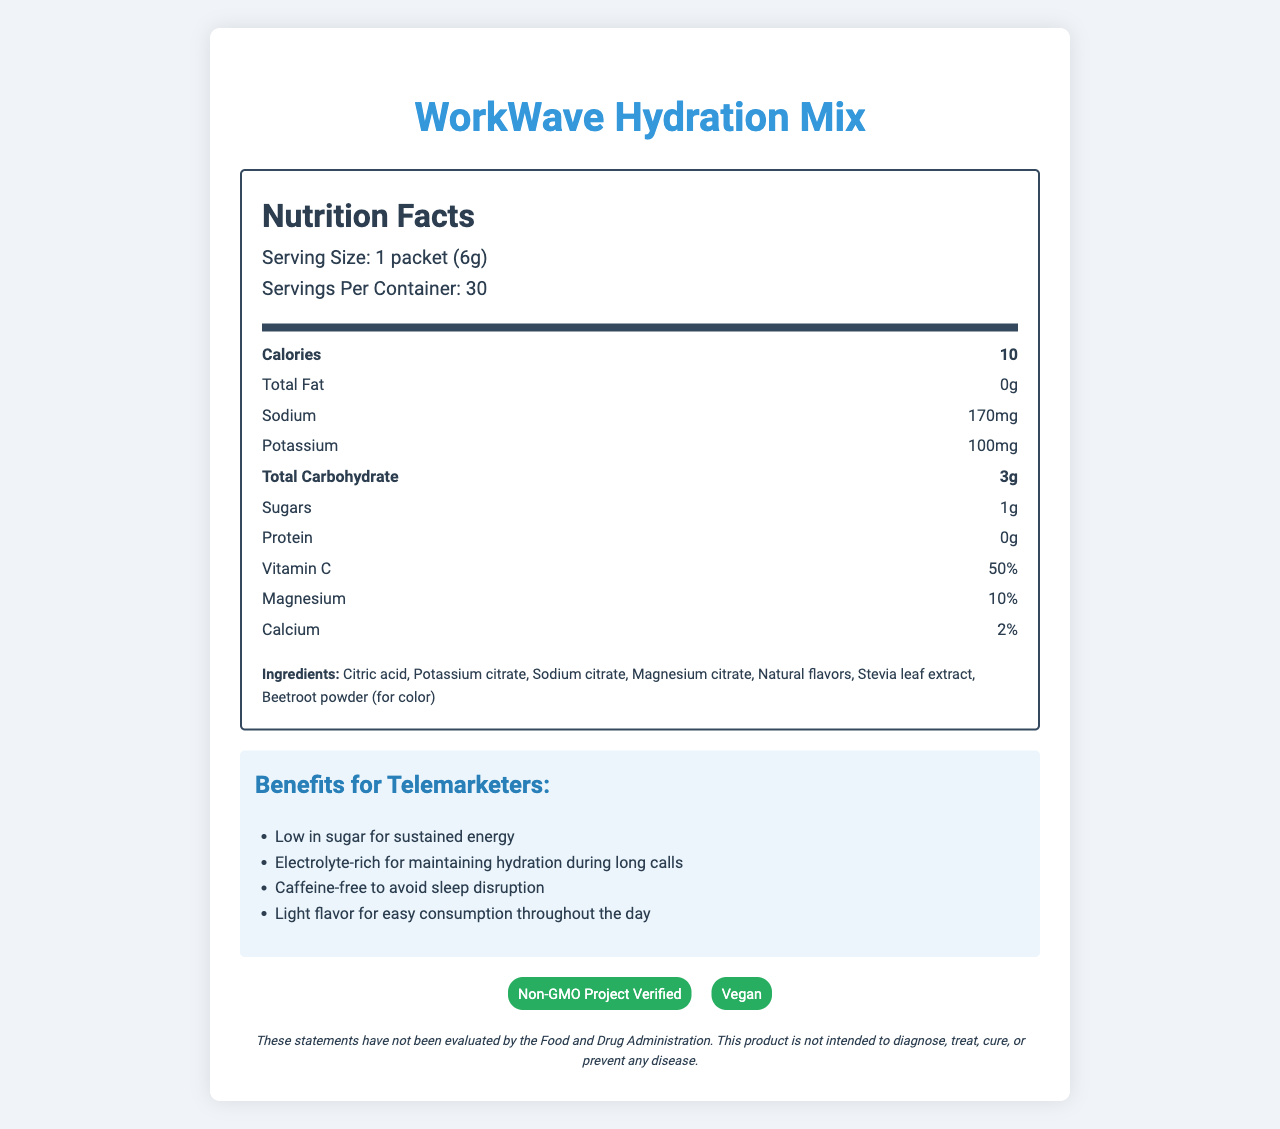What is the serving size of WorkWave Hydration Mix? The serving size is clearly stated under the nutrition facts header where it mentions "Serving Size: 1 packet (6g)."
Answer: 1 packet (6g) How many calories are in one serving of the hydration mix? The number of calories per serving is listed directly in the nutrition facts, stating "Calories: 10".
Answer: 10 What is the main benefit of the WorkWave Hydration Mix for telemarketers? The benefits are listed in a dedicated section, with "Low in sugar for sustained energy" being one of the primary benefits highlighted.
Answer: Low in sugar for sustained energy What percentage of Daily Value is the Vitamin C in one serving? Under the nutrition facts, it mentions "Vitamin C: 50%."
Answer: 50% What facilities does WorkWave Hydration Mix get processed in? This information is listed in the allergen information section near the bottom of the document.
Answer: Produced in a facility that also processes soy and milk Which of the following ingredients are in the WorkWave Hydration Mix? (Select all that apply) A. Citric acid B. Stevia leaf extract C. Beetroot powder D. High fructose corn syrup E. Artificial flavors The ingredients section lists "Citric acid", "Stevia leaf extract", and "Beetroot powder (for color)" but does not mention "High fructose corn syrup" or "Artificial flavors".
Answer: A, B, C What are two certifications held by the WorkWave Hydration Mix? The certifications section at the bottom of the document lists "Non-GMO Project Verified" and "Vegan."
Answer: Non-GMO Project Verified, Vegan Is this product suitable for someone avoiding caffeine? The benefits section mentions that the drink mix is "Caffeine-free to avoid sleep disruption," which confirms it is suitable for someone avoiding caffeine.
Answer: Yes Does WorkWave Hydration Mix contain any fat? The nutrition facts clearly state "Total Fat: 0g."
Answer: No Summarize the main points of the WorkWave Hydration Mix document. The detailed explanation of the document includes an overview of the product benefits for telemarketers, nutritional values, ingredients, allergen information, and certifications.
Answer: The WorkWave Hydration Mix is a low-sugar, electrolyte-rich drink mix designed specifically for telemarketers to maintain hydration and energy during work hours. It contains 10 calories per serving, is caffeine-free, and is produced in a facility that processes soy and milk. The mix comes with several benefits such as being Non-GMO Project Verified and Vegan, and designed to be light-tasting and easily consumable throughout the day. The document includes detailed nutritional information, ingredients, directions for use, and storage instructions. What is the storage recommendation for the WorkWave Hydration Mix? Storage instructions at the bottom of the document recommend storing the product in a cool, dry place.
Answer: Store in a cool, dry place How many servings are there per container of the WorkWave Hydration Mix? This information is listed below the serving size under the nutrition facts header as "Servings Per Container: 30."
Answer: 30 How is WorkWave Hydration Mix beneficial for sleep schedules? One of the benefits listed is that the drink mix is "Caffeine-free to avoid sleep disruption," thus making it advantageous for maintaining sleep schedules.
Answer: Caffeine-free to avoid sleep disruption Does the document provide information about the country of origin? The document does not mention the country of origin or any related information.
Answer: Cannot be determined 